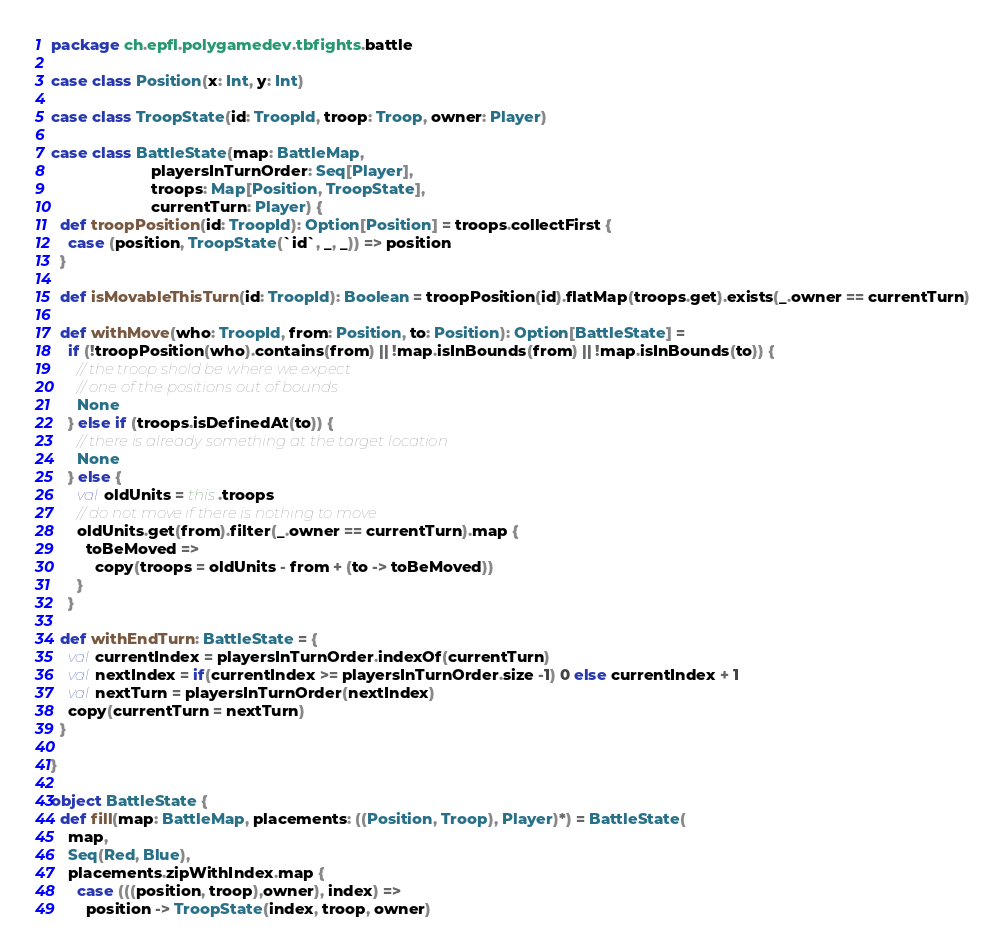Convert code to text. <code><loc_0><loc_0><loc_500><loc_500><_Scala_>package ch.epfl.polygamedev.tbfights.battle

case class Position(x: Int, y: Int)

case class TroopState(id: TroopId, troop: Troop, owner: Player)

case class BattleState(map: BattleMap,
                       playersInTurnOrder: Seq[Player],
                       troops: Map[Position, TroopState],
                       currentTurn: Player) {
  def troopPosition(id: TroopId): Option[Position] = troops.collectFirst {
    case (position, TroopState(`id`, _, _)) => position
  }

  def isMovableThisTurn(id: TroopId): Boolean = troopPosition(id).flatMap(troops.get).exists(_.owner == currentTurn)

  def withMove(who: TroopId, from: Position, to: Position): Option[BattleState] =
    if (!troopPosition(who).contains(from) || !map.isInBounds(from) || !map.isInBounds(to)) {
      // the troop shold be where we expect
      // one of the positions out of bounds
      None
    } else if (troops.isDefinedAt(to)) {
      // there is already something at the target location
      None
    } else {
      val oldUnits = this.troops
      // do not move if there is nothing to move
      oldUnits.get(from).filter(_.owner == currentTurn).map {
        toBeMoved =>
          copy(troops = oldUnits - from + (to -> toBeMoved))
      }
    }

  def withEndTurn: BattleState = {
    val currentIndex = playersInTurnOrder.indexOf(currentTurn)
    val nextIndex = if(currentIndex >= playersInTurnOrder.size -1) 0 else currentIndex + 1
    val nextTurn = playersInTurnOrder(nextIndex)
    copy(currentTurn = nextTurn)
  }

}

object BattleState {
  def fill(map: BattleMap, placements: ((Position, Troop), Player)*) = BattleState(
    map,
    Seq(Red, Blue),
    placements.zipWithIndex.map {
      case (((position, troop),owner), index) =>
        position -> TroopState(index, troop, owner)</code> 